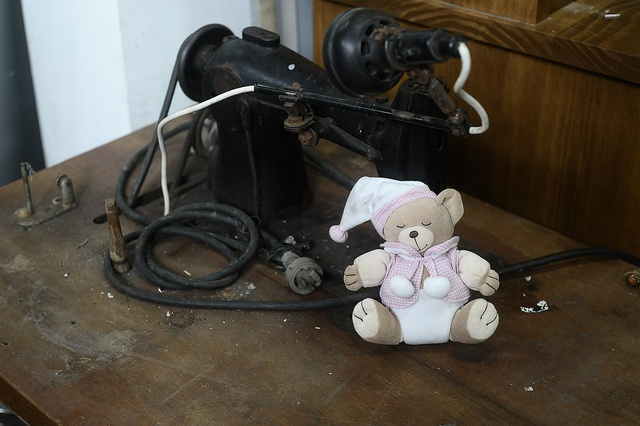Describe the objects in this image and their specific colors. I can see dining table in gray and black tones and teddy bear in gray, lightgray, darkgray, and black tones in this image. 